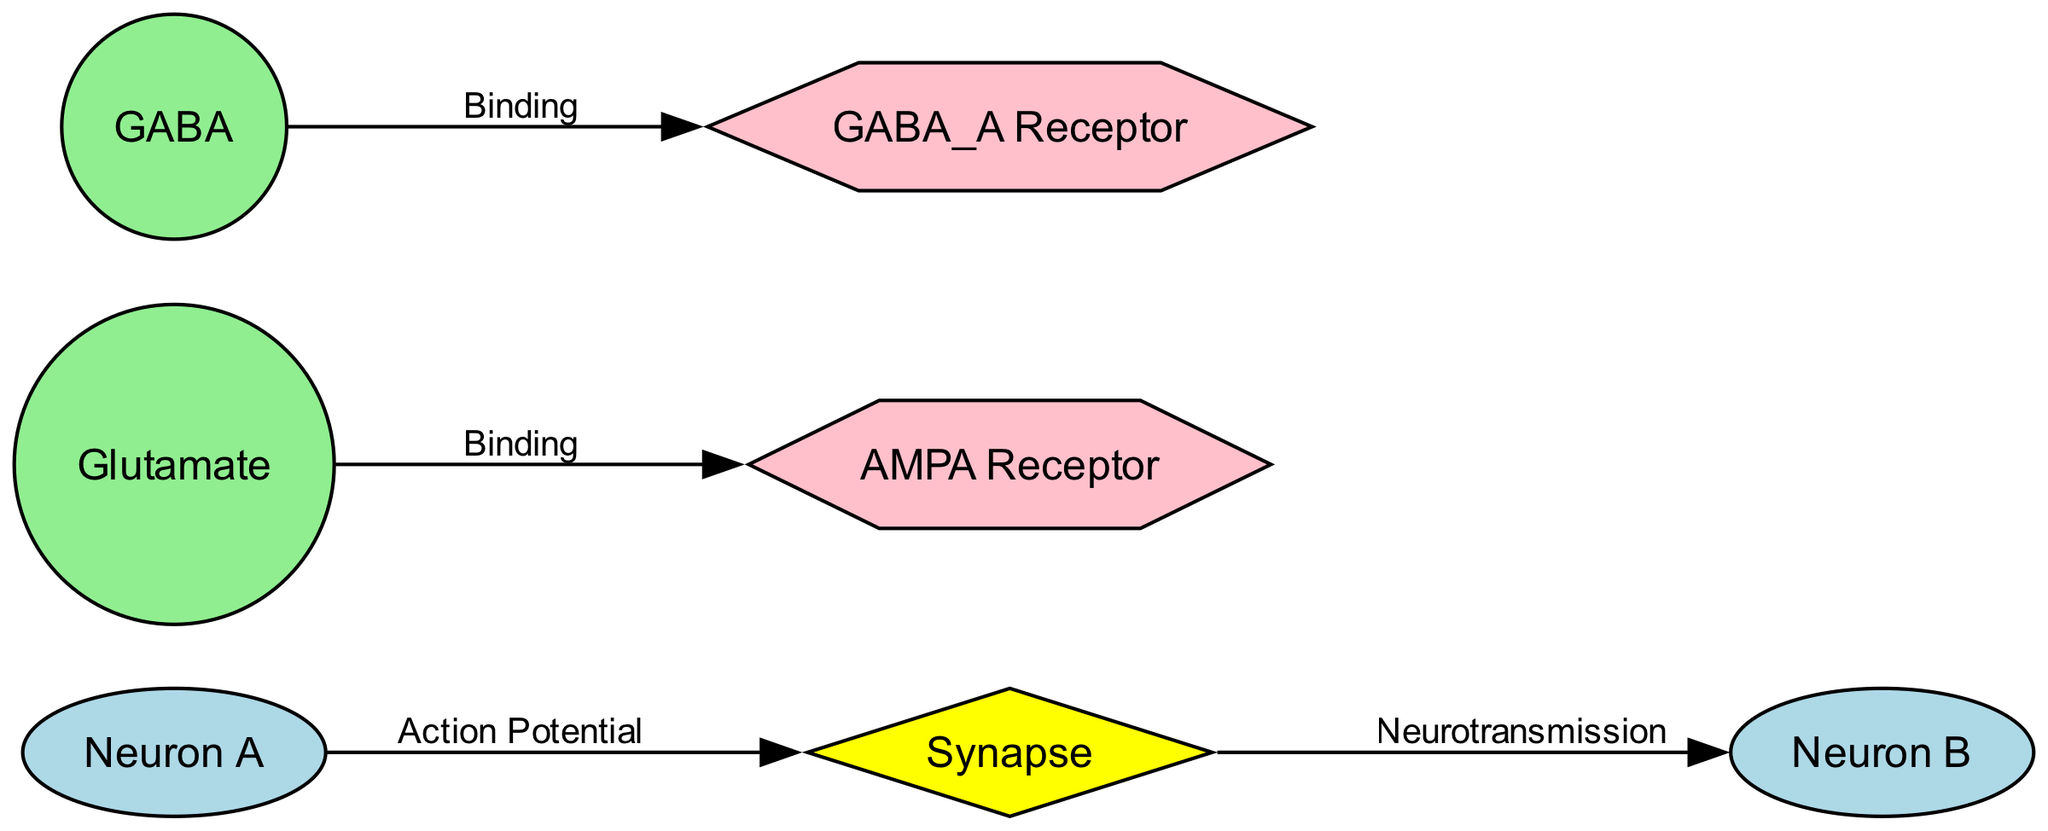What is the label of the presynaptic neuron? The presynaptic neuron is labeled as "Neuron A" in the diagram. This can be identified in the nodes section where it specifically identifies the presynaptic neuron as Neuron A.
Answer: Neuron A How many neurotransmitters are represented in the diagram? The diagram includes two neurotransmitters: Glutamate and GABA. By counting the nodes listed under neurotransmitters, we find two distinct entries.
Answer: 2 What type of receptor does Glutamate bind to? Glutamate binds to the AMPA receptor, as indicated by the binding edge in the diagram that connects Glutamate to its corresponding receptor.
Answer: AMPA Receptor What connection indicates neurotransmission from the synapse to a neuron? The edge labeled "Neurotransmission" indicates the transfer of neurotransmitters from the synapse to the postsynaptic neuron, represented as the connection going from Synapse to Neuron B.
Answer: Neurotransmission Which neurotransmitter is inhibitory? GABA is the inhibitory neurotransmitter specified in the diagram, clearly marked as such in the node description for Neurotransmitter2.
Answer: GABA What action potential triggers neurotransmitter release? The edge labeled "Action Potential" describes the electrical signal that initiates the release of neurotransmitters from Neuron A to the synapse, illustrating the process of activation in neuronal communication.
Answer: Action Potential What is the relationship between GABA and its receptor? GABA binds to the GABA_A receptor, as shown by the binding edge in the diagram connecting the neurotransmitter GABA to its respective receptor, indicating their functional relationship.
Answer: GABA_A Receptor How many edges are present in the diagram? The diagram includes four edges, as listed under the edges section, connecting the various nodes through their respective interactions.
Answer: 4 What shape represents the synapse? The synapse is represented by a diamond shape in the diagram, which is specifically indicated in the node style attributes.
Answer: Diamond 